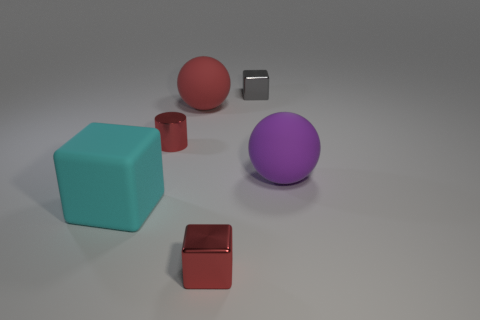What material is the big ball that is in front of the tiny red object behind the small metal cube that is in front of the tiny red metal cylinder made of?
Your answer should be compact. Rubber. Is the shape of the gray metal object the same as the red matte thing?
Make the answer very short. No. What is the material of the purple thing that is the same shape as the red matte object?
Keep it short and to the point. Rubber. How many large things have the same color as the large block?
Make the answer very short. 0. The red object that is the same material as the small red block is what size?
Your response must be concise. Small. What number of gray objects are small cylinders or big cubes?
Make the answer very short. 0. There is a small block that is behind the red sphere; how many purple rubber balls are to the left of it?
Offer a very short reply. 0. Are there more cyan objects that are on the right side of the red block than gray blocks that are in front of the big cyan rubber cube?
Make the answer very short. No. What is the small red cylinder made of?
Keep it short and to the point. Metal. Are there any purple matte cylinders of the same size as the purple object?
Keep it short and to the point. No. 